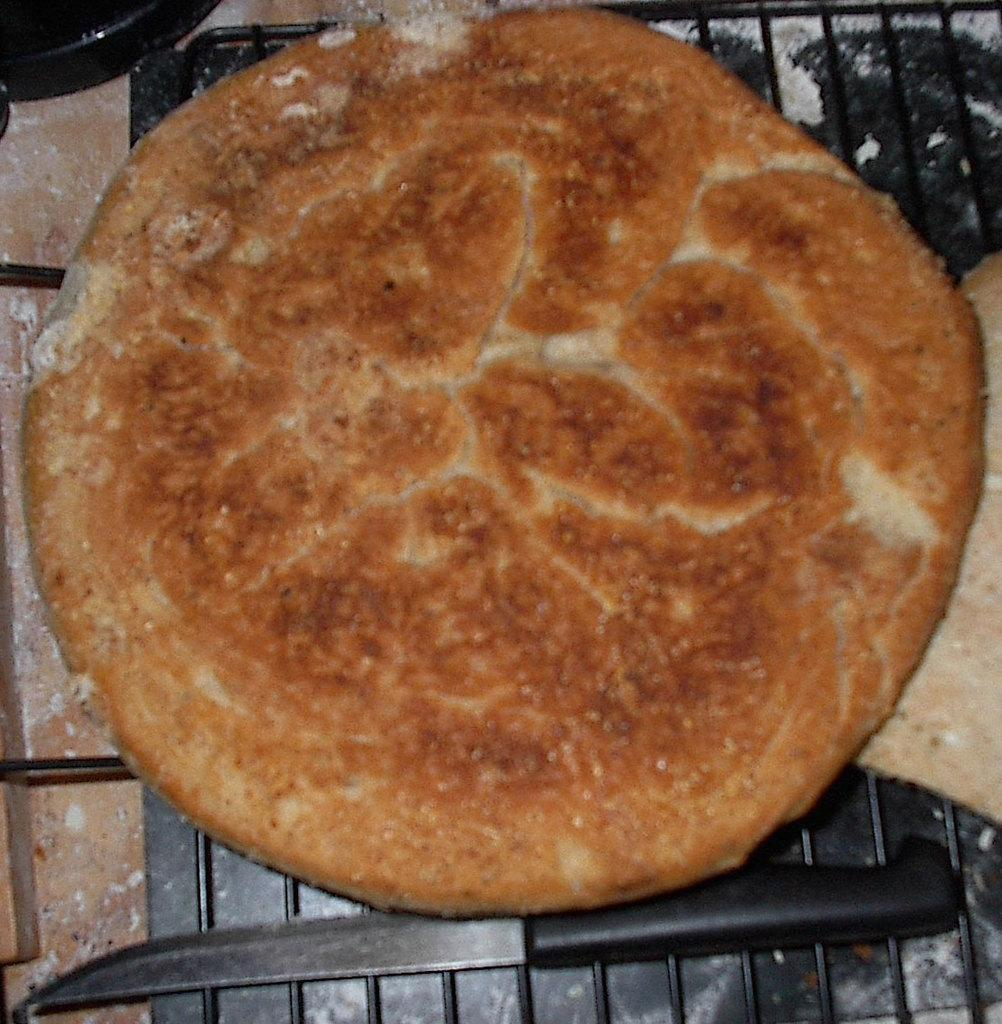What type of utensil is present in the image? There is a knife in the image. What is the knife placed near in the image? There is: There is a dish in the image. What type of operation is the spy performing in the image? There is no operation or spy present in the image; it only features a knife and a dish. 